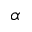Convert formula to latex. <formula><loc_0><loc_0><loc_500><loc_500>\alpha</formula> 